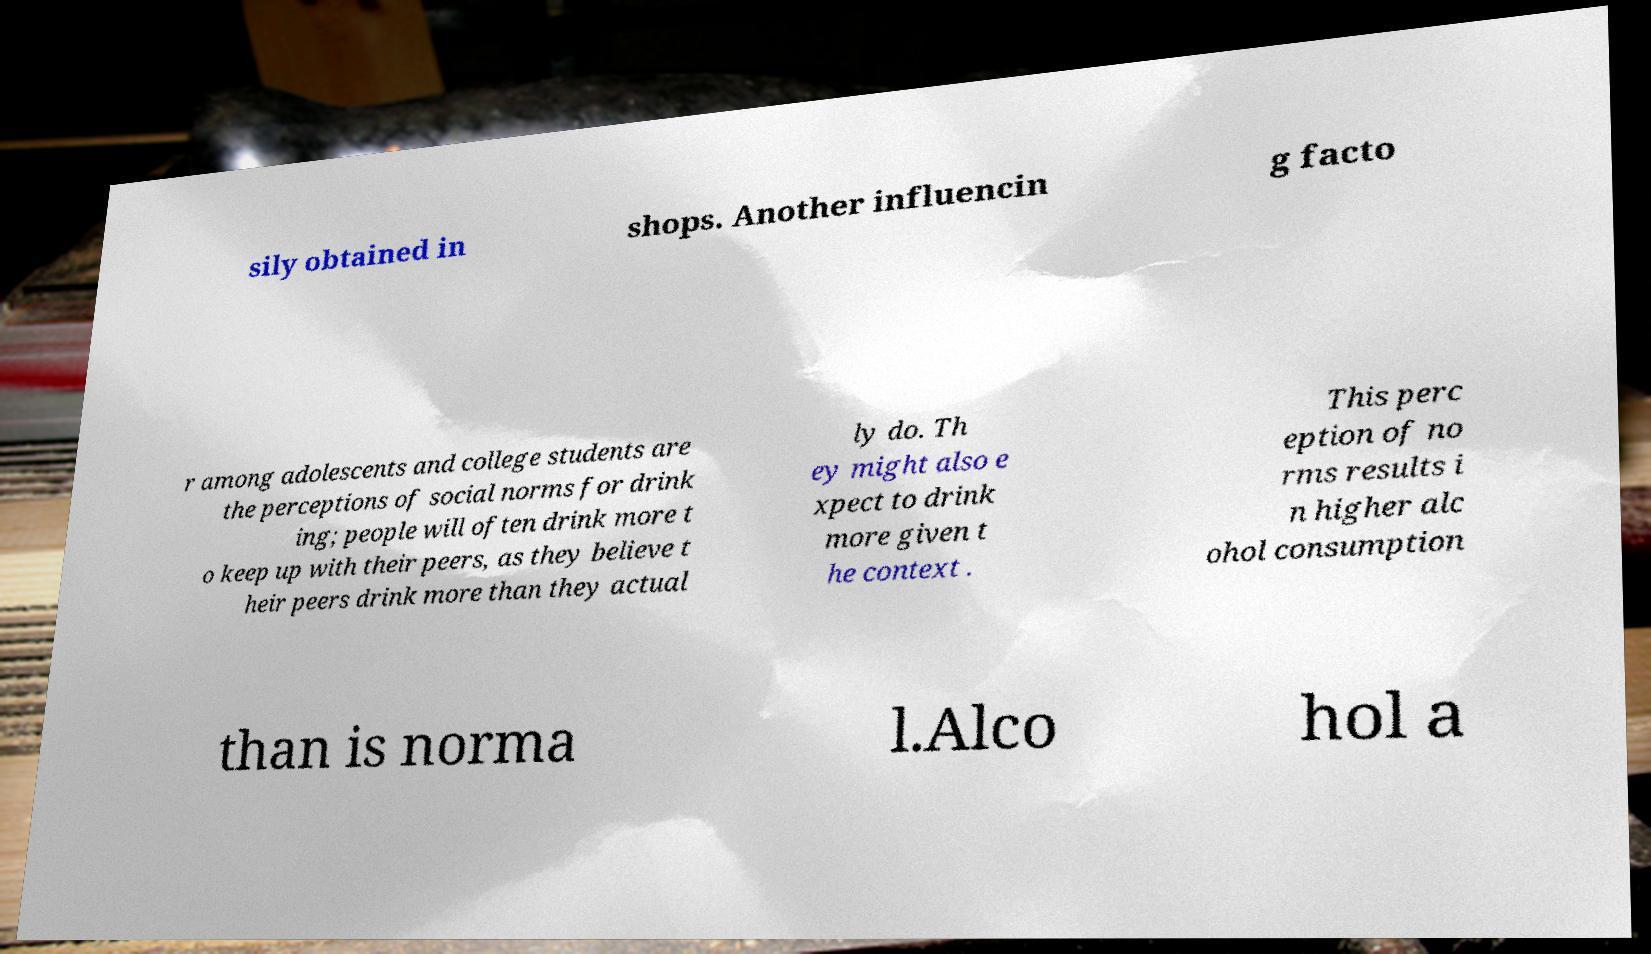Please identify and transcribe the text found in this image. sily obtained in shops. Another influencin g facto r among adolescents and college students are the perceptions of social norms for drink ing; people will often drink more t o keep up with their peers, as they believe t heir peers drink more than they actual ly do. Th ey might also e xpect to drink more given t he context . This perc eption of no rms results i n higher alc ohol consumption than is norma l.Alco hol a 